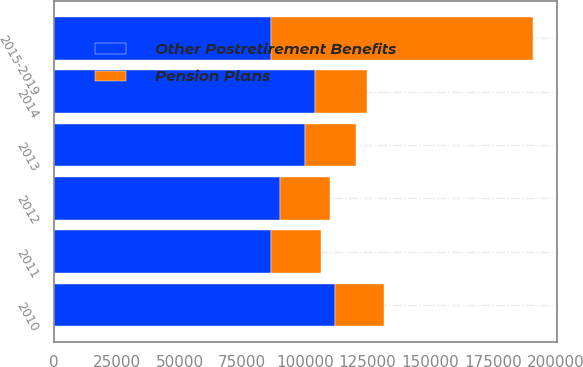Convert chart. <chart><loc_0><loc_0><loc_500><loc_500><stacked_bar_chart><ecel><fcel>2010<fcel>2011<fcel>2012<fcel>2013<fcel>2014<fcel>2015-2019<nl><fcel>Other Postretirement Benefits<fcel>111809<fcel>86473<fcel>89994<fcel>99955<fcel>103853<fcel>86473<nl><fcel>Pension Plans<fcel>19597<fcel>19831<fcel>20096<fcel>20407<fcel>20734<fcel>104490<nl></chart> 